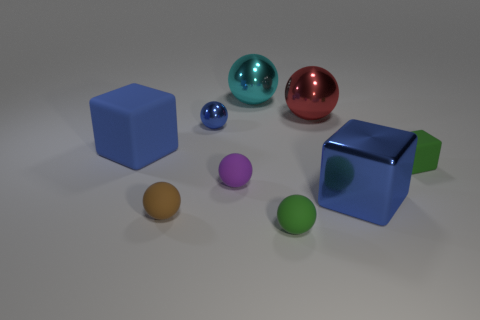Subtract all blue metal balls. How many balls are left? 5 Subtract all green cylinders. How many blue blocks are left? 2 Subtract all green cubes. How many cubes are left? 2 Add 7 tiny brown balls. How many tiny brown balls are left? 8 Add 3 brown things. How many brown things exist? 4 Subtract 1 brown spheres. How many objects are left? 8 Subtract all blocks. How many objects are left? 6 Subtract 3 blocks. How many blocks are left? 0 Subtract all gray balls. Subtract all blue cubes. How many balls are left? 6 Subtract all small blocks. Subtract all big red balls. How many objects are left? 7 